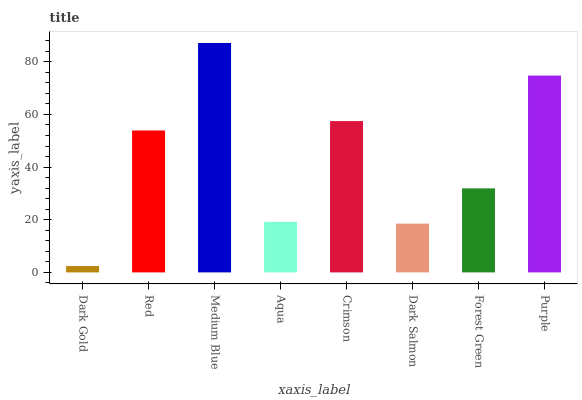Is Dark Gold the minimum?
Answer yes or no. Yes. Is Medium Blue the maximum?
Answer yes or no. Yes. Is Red the minimum?
Answer yes or no. No. Is Red the maximum?
Answer yes or no. No. Is Red greater than Dark Gold?
Answer yes or no. Yes. Is Dark Gold less than Red?
Answer yes or no. Yes. Is Dark Gold greater than Red?
Answer yes or no. No. Is Red less than Dark Gold?
Answer yes or no. No. Is Red the high median?
Answer yes or no. Yes. Is Forest Green the low median?
Answer yes or no. Yes. Is Forest Green the high median?
Answer yes or no. No. Is Purple the low median?
Answer yes or no. No. 